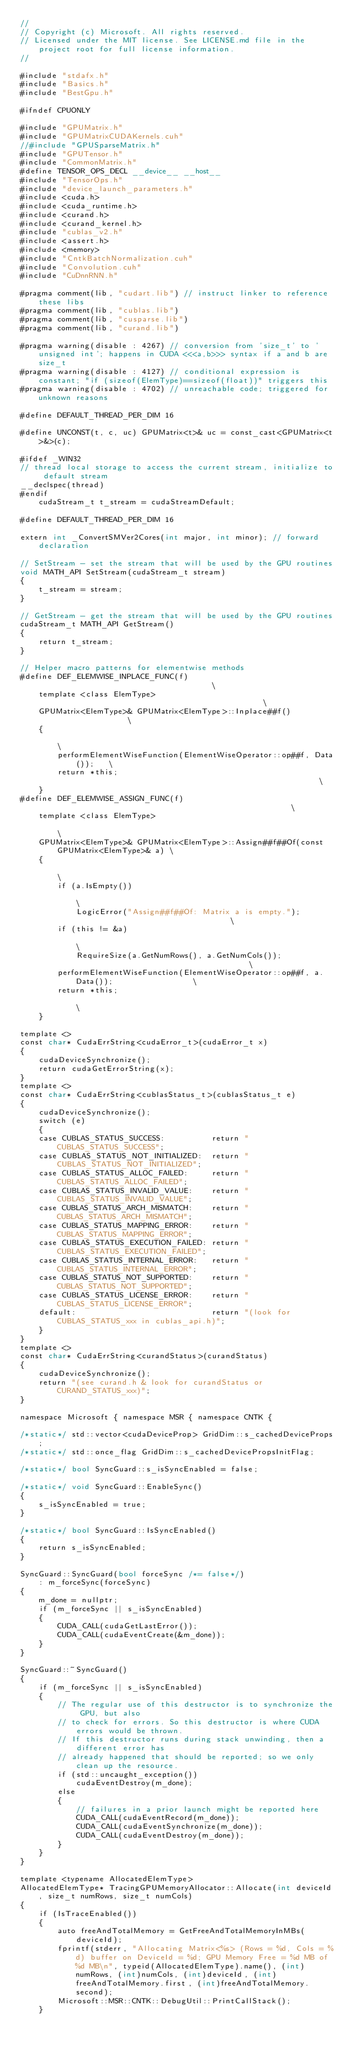<code> <loc_0><loc_0><loc_500><loc_500><_Cuda_>//
// Copyright (c) Microsoft. All rights reserved.
// Licensed under the MIT license. See LICENSE.md file in the project root for full license information.
//

#include "stdafx.h"
#include "Basics.h"
#include "BestGpu.h"

#ifndef CPUONLY

#include "GPUMatrix.h"
#include "GPUMatrixCUDAKernels.cuh"
//#include "GPUSparseMatrix.h"
#include "GPUTensor.h"
#include "CommonMatrix.h"
#define TENSOR_OPS_DECL __device__ __host__
#include "TensorOps.h"
#include "device_launch_parameters.h"
#include <cuda.h>
#include <cuda_runtime.h>
#include <curand.h>
#include <curand_kernel.h>
#include "cublas_v2.h"
#include <assert.h>
#include <memory>
#include "CntkBatchNormalization.cuh"
#include "Convolution.cuh"
#include "CuDnnRNN.h"

#pragma comment(lib, "cudart.lib") // instruct linker to reference these libs
#pragma comment(lib, "cublas.lib")
#pragma comment(lib, "cusparse.lib")
#pragma comment(lib, "curand.lib")

#pragma warning(disable : 4267) // conversion from 'size_t' to 'unsigned int'; happens in CUDA <<<a,b>>> syntax if a and b are size_t
#pragma warning(disable : 4127) // conditional expression is constant; "if (sizeof(ElemType)==sizeof(float))" triggers this
#pragma warning(disable : 4702) // unreachable code; triggered for unknown reasons

#define DEFAULT_THREAD_PER_DIM 16

#define UNCONST(t, c, uc) GPUMatrix<t>& uc = const_cast<GPUMatrix<t>&>(c);

#ifdef _WIN32
// thread local storage to access the current stream, initialize to default stream
__declspec(thread)
#endif
    cudaStream_t t_stream = cudaStreamDefault;

#define DEFAULT_THREAD_PER_DIM 16

extern int _ConvertSMVer2Cores(int major, int minor); // forward declaration

// SetStream - set the stream that will be used by the GPU routines
void MATH_API SetStream(cudaStream_t stream)
{
    t_stream = stream;
}

// GetStream - get the stream that will be used by the GPU routines
cudaStream_t MATH_API GetStream()
{
    return t_stream;
}

// Helper macro patterns for elementwise methods
#define DEF_ELEMWISE_INPLACE_FUNC(f)                                      \
    template <class ElemType>                                             \
    GPUMatrix<ElemType>& GPUMatrix<ElemType>::Inplace##f()                \
    {                                                                     \
        performElementWiseFunction(ElementWiseOperator::op##f, Data());   \
        return *this;                                                     \
    }
#define DEF_ELEMWISE_ASSIGN_FUNC(f)                                                       \
    template <class ElemType>                                                             \
    GPUMatrix<ElemType>& GPUMatrix<ElemType>::Assign##f##Of(const GPUMatrix<ElemType>& a) \
    {                                                                                     \
        if (a.IsEmpty())                                                                  \
            LogicError("Assign##f##Of: Matrix a is empty.");                              \
        if (this != &a)                                                                   \
            RequireSize(a.GetNumRows(), a.GetNumCols());                                  \
        performElementWiseFunction(ElementWiseOperator::op##f, a.Data());                 \
        return *this;                                                                     \
    }

template <>
const char* CudaErrString<cudaError_t>(cudaError_t x)
{
    cudaDeviceSynchronize();
    return cudaGetErrorString(x);
}
template <>
const char* CudaErrString<cublasStatus_t>(cublasStatus_t e)
{
    cudaDeviceSynchronize();
    switch (e)
    {
    case CUBLAS_STATUS_SUCCESS:          return "CUBLAS_STATUS_SUCCESS";
    case CUBLAS_STATUS_NOT_INITIALIZED:  return "CUBLAS_STATUS_NOT_INITIALIZED";
    case CUBLAS_STATUS_ALLOC_FAILED:     return "CUBLAS_STATUS_ALLOC_FAILED";
    case CUBLAS_STATUS_INVALID_VALUE:    return "CUBLAS_STATUS_INVALID_VALUE";
    case CUBLAS_STATUS_ARCH_MISMATCH:    return "CUBLAS_STATUS_ARCH_MISMATCH";
    case CUBLAS_STATUS_MAPPING_ERROR:    return "CUBLAS_STATUS_MAPPING_ERROR";
    case CUBLAS_STATUS_EXECUTION_FAILED: return "CUBLAS_STATUS_EXECUTION_FAILED";
    case CUBLAS_STATUS_INTERNAL_ERROR:   return "CUBLAS_STATUS_INTERNAL_ERROR";
    case CUBLAS_STATUS_NOT_SUPPORTED:    return "CUBLAS_STATUS_NOT_SUPPORTED";
    case CUBLAS_STATUS_LICENSE_ERROR:    return "CUBLAS_STATUS_LICENSE_ERROR";
    default:                             return "(look for CUBLAS_STATUS_xxx in cublas_api.h)";
    }
}
template <>
const char* CudaErrString<curandStatus>(curandStatus)
{
    cudaDeviceSynchronize();
    return "(see curand.h & look for curandStatus or CURAND_STATUS_xxx)";
}

namespace Microsoft { namespace MSR { namespace CNTK {

/*static*/ std::vector<cudaDeviceProp> GridDim::s_cachedDeviceProps;
/*static*/ std::once_flag GridDim::s_cachedDevicePropsInitFlag;

/*static*/ bool SyncGuard::s_isSyncEnabled = false;

/*static*/ void SyncGuard::EnableSync()
{
    s_isSyncEnabled = true;
}

/*static*/ bool SyncGuard::IsSyncEnabled() 
{
    return s_isSyncEnabled; 
}

SyncGuard::SyncGuard(bool forceSync /*= false*/)
    : m_forceSync(forceSync)
{
    m_done = nullptr;
    if (m_forceSync || s_isSyncEnabled)
    {
        CUDA_CALL(cudaGetLastError());
        CUDA_CALL(cudaEventCreate(&m_done));
    }
}

SyncGuard::~SyncGuard()
{
    if (m_forceSync || s_isSyncEnabled)
    {
        // The regular use of this destructor is to synchronize the GPU, but also
        // to check for errors. So this destructor is where CUDA errors would be thrown.
        // If this destructor runs during stack unwinding, then a different error has
        // already happened that should be reported; so we only clean up the resource.
        if (std::uncaught_exception())
            cudaEventDestroy(m_done);
        else
        {
            // failures in a prior launch might be reported here
            CUDA_CALL(cudaEventRecord(m_done));
            CUDA_CALL(cudaEventSynchronize(m_done));
            CUDA_CALL(cudaEventDestroy(m_done));
        }
    }
}

template <typename AllocatedElemType>
AllocatedElemType* TracingGPUMemoryAllocator::Allocate(int deviceId, size_t numRows, size_t numCols)
{
    if (IsTraceEnabled())
    {
        auto freeAndTotalMemory = GetFreeAndTotalMemoryInMBs(deviceId);
        fprintf(stderr, "Allocating Matrix<%s> (Rows = %d, Cols = %d) buffer on DeviceId = %d; GPU Memory Free = %d MB of %d MB\n", typeid(AllocatedElemType).name(), (int)numRows, (int)numCols, (int)deviceId, (int)freeAndTotalMemory.first, (int)freeAndTotalMemory.second);
        Microsoft::MSR::CNTK::DebugUtil::PrintCallStack();
    }
</code> 